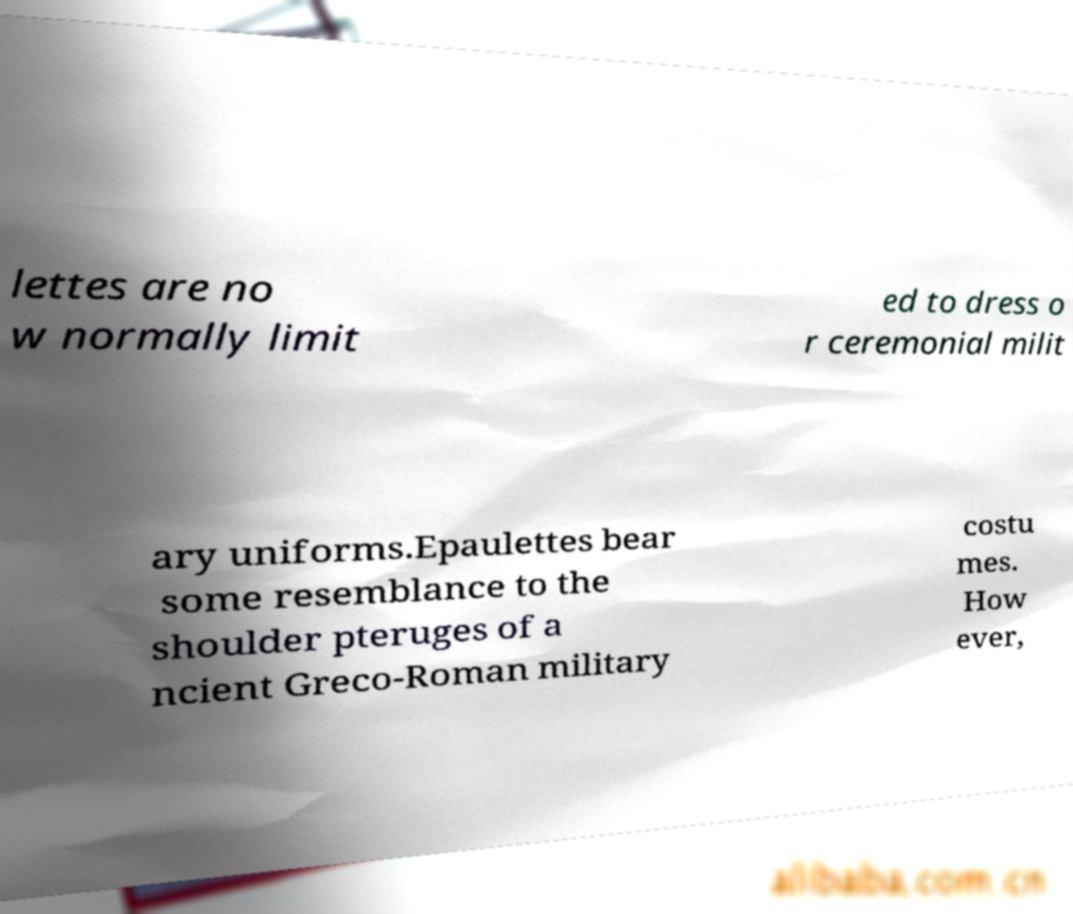Can you read and provide the text displayed in the image?This photo seems to have some interesting text. Can you extract and type it out for me? lettes are no w normally limit ed to dress o r ceremonial milit ary uniforms.Epaulettes bear some resemblance to the shoulder pteruges of a ncient Greco-Roman military costu mes. How ever, 